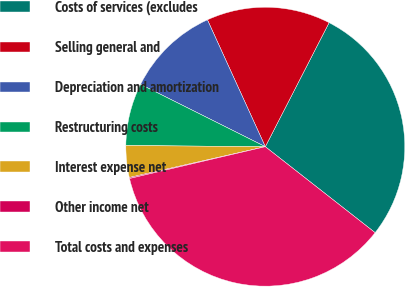Convert chart. <chart><loc_0><loc_0><loc_500><loc_500><pie_chart><fcel>Costs of services (excludes<fcel>Selling general and<fcel>Depreciation and amortization<fcel>Restructuring costs<fcel>Interest expense net<fcel>Other income net<fcel>Total costs and expenses<nl><fcel>28.01%<fcel>14.37%<fcel>10.81%<fcel>7.24%<fcel>3.68%<fcel>0.12%<fcel>35.76%<nl></chart> 